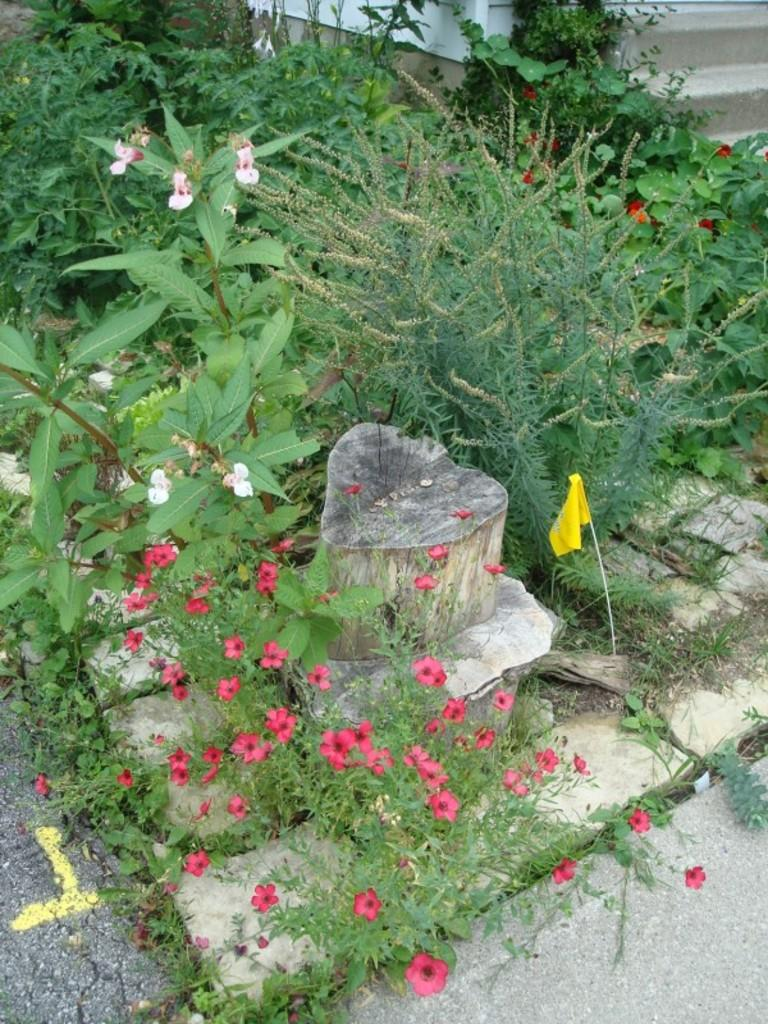What type of plants are featured in the image? There are plants with flowers in the image. Where are the plants located in the image? The plants are at the center of the image. What can be seen on the left side of the image? There is a road on the left side of the image. What architectural feature is present on the right side of the image? There are stairs on the right side of the image. What type of behavior is exhibited by the plants during breakfast in the image? There is no reference to breakfast or any behavior exhibited by the plants in the image. 